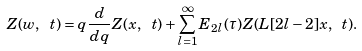Convert formula to latex. <formula><loc_0><loc_0><loc_500><loc_500>Z ( w , \ t ) = q \frac { d } { d q } Z ( x , \ t ) + \sum _ { l = 1 } ^ { \infty } E _ { 2 l } ( \tau ) Z ( L [ 2 l - 2 ] x , \ t ) .</formula> 